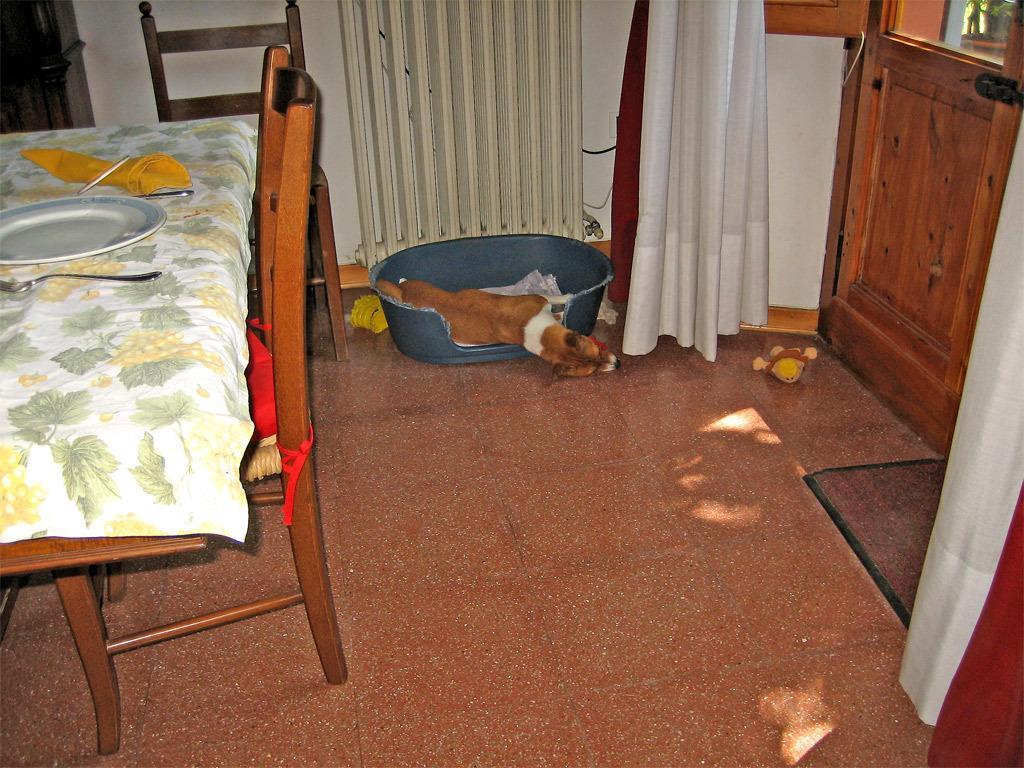Could you give a brief overview of what you see in this image? As we can see in the image there is a white color wall, curtain, dining table and a dog. On dining table there is a plate and spoons. 